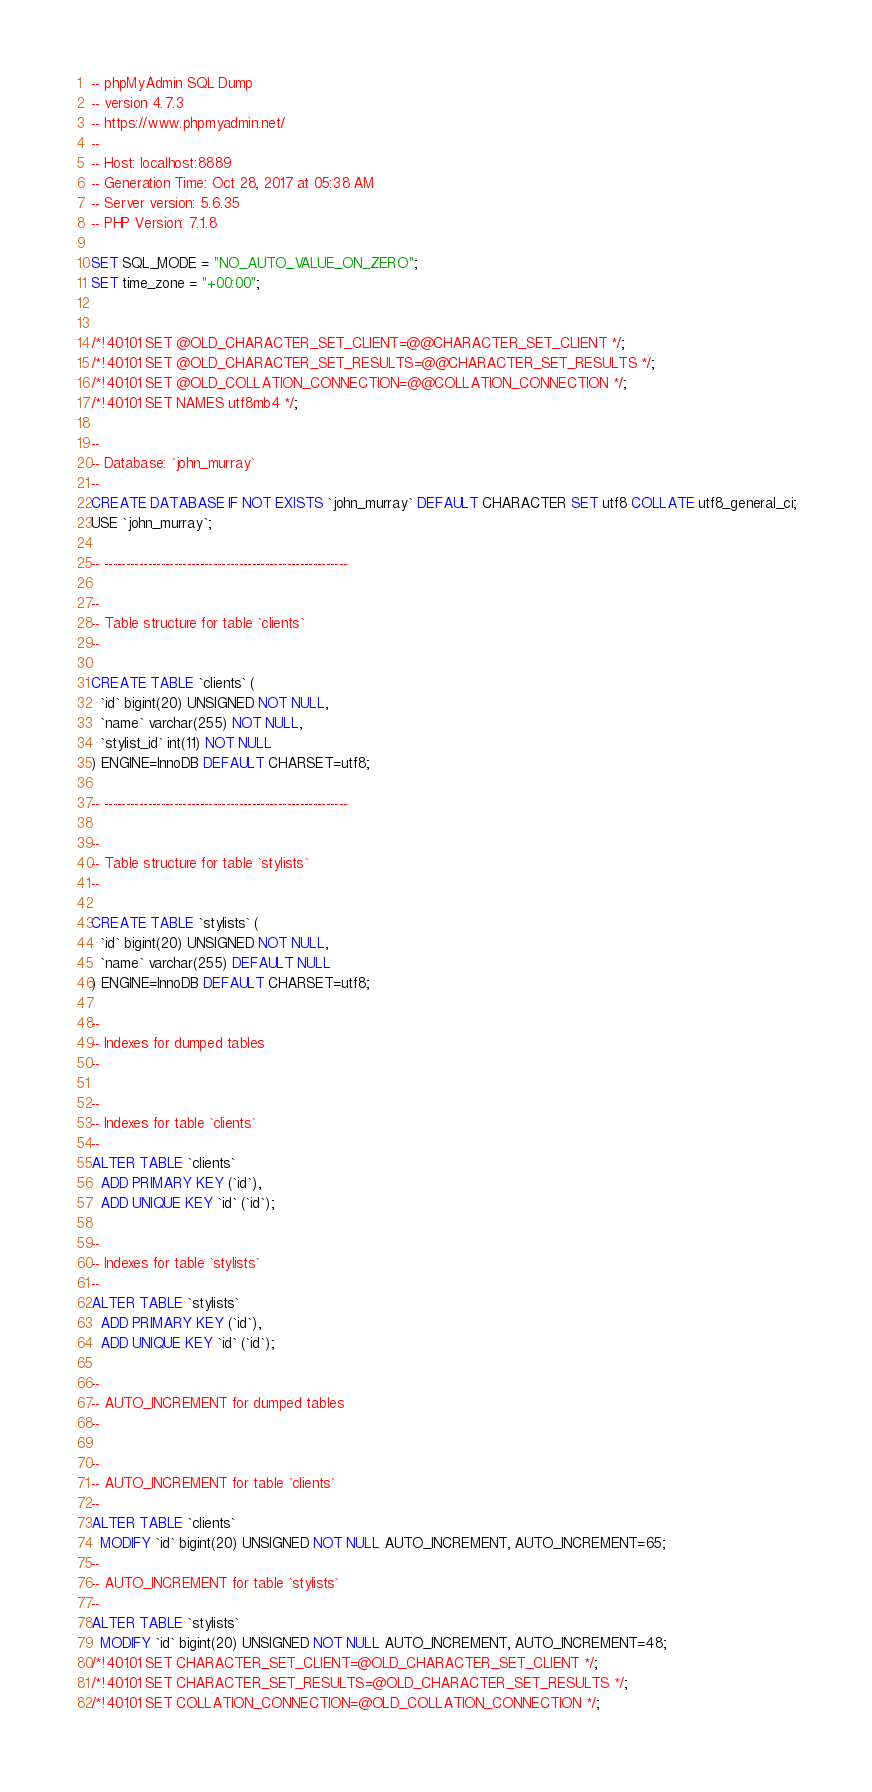Convert code to text. <code><loc_0><loc_0><loc_500><loc_500><_SQL_>-- phpMyAdmin SQL Dump
-- version 4.7.3
-- https://www.phpmyadmin.net/
--
-- Host: localhost:8889
-- Generation Time: Oct 28, 2017 at 05:38 AM
-- Server version: 5.6.35
-- PHP Version: 7.1.8

SET SQL_MODE = "NO_AUTO_VALUE_ON_ZERO";
SET time_zone = "+00:00";


/*!40101 SET @OLD_CHARACTER_SET_CLIENT=@@CHARACTER_SET_CLIENT */;
/*!40101 SET @OLD_CHARACTER_SET_RESULTS=@@CHARACTER_SET_RESULTS */;
/*!40101 SET @OLD_COLLATION_CONNECTION=@@COLLATION_CONNECTION */;
/*!40101 SET NAMES utf8mb4 */;

--
-- Database: `john_murray`
--
CREATE DATABASE IF NOT EXISTS `john_murray` DEFAULT CHARACTER SET utf8 COLLATE utf8_general_ci;
USE `john_murray`;

-- --------------------------------------------------------

--
-- Table structure for table `clients`
--

CREATE TABLE `clients` (
  `id` bigint(20) UNSIGNED NOT NULL,
  `name` varchar(255) NOT NULL,
  `stylist_id` int(11) NOT NULL
) ENGINE=InnoDB DEFAULT CHARSET=utf8;

-- --------------------------------------------------------

--
-- Table structure for table `stylists`
--

CREATE TABLE `stylists` (
  `id` bigint(20) UNSIGNED NOT NULL,
  `name` varchar(255) DEFAULT NULL
) ENGINE=InnoDB DEFAULT CHARSET=utf8;

--
-- Indexes for dumped tables
--

--
-- Indexes for table `clients`
--
ALTER TABLE `clients`
  ADD PRIMARY KEY (`id`),
  ADD UNIQUE KEY `id` (`id`);

--
-- Indexes for table `stylists`
--
ALTER TABLE `stylists`
  ADD PRIMARY KEY (`id`),
  ADD UNIQUE KEY `id` (`id`);

--
-- AUTO_INCREMENT for dumped tables
--

--
-- AUTO_INCREMENT for table `clients`
--
ALTER TABLE `clients`
  MODIFY `id` bigint(20) UNSIGNED NOT NULL AUTO_INCREMENT, AUTO_INCREMENT=65;
--
-- AUTO_INCREMENT for table `stylists`
--
ALTER TABLE `stylists`
  MODIFY `id` bigint(20) UNSIGNED NOT NULL AUTO_INCREMENT, AUTO_INCREMENT=48;
/*!40101 SET CHARACTER_SET_CLIENT=@OLD_CHARACTER_SET_CLIENT */;
/*!40101 SET CHARACTER_SET_RESULTS=@OLD_CHARACTER_SET_RESULTS */;
/*!40101 SET COLLATION_CONNECTION=@OLD_COLLATION_CONNECTION */;
</code> 